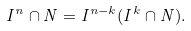Convert formula to latex. <formula><loc_0><loc_0><loc_500><loc_500>I ^ { n } \cap N = I ^ { n - k } ( I ^ { k } \cap N ) .</formula> 